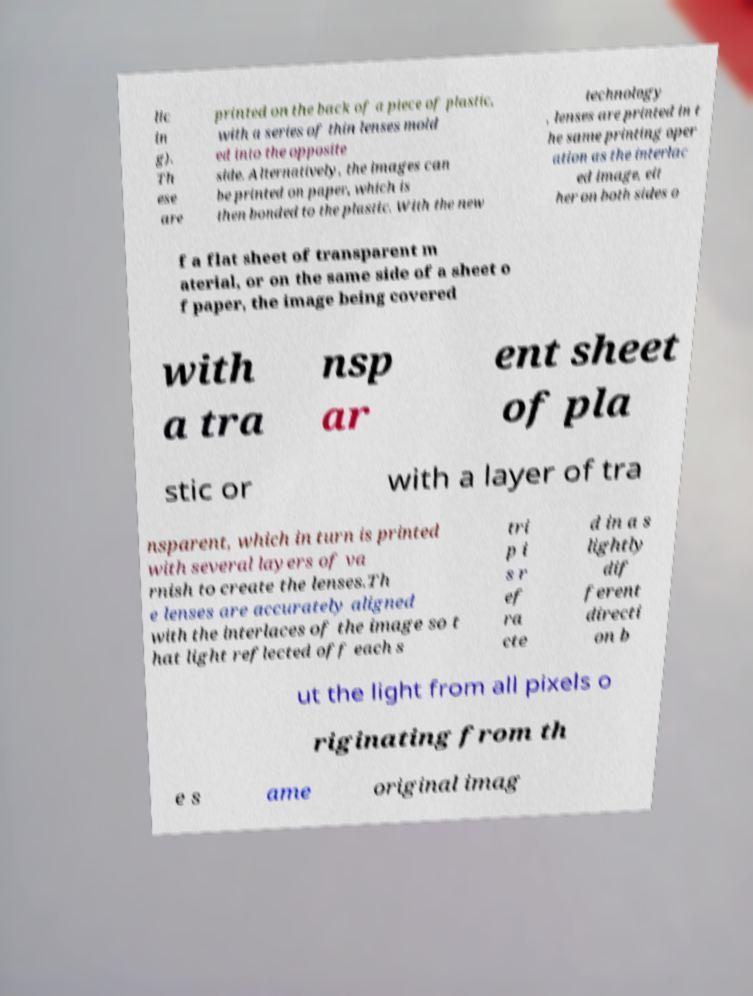Can you accurately transcribe the text from the provided image for me? lic in g). Th ese are printed on the back of a piece of plastic, with a series of thin lenses mold ed into the opposite side. Alternatively, the images can be printed on paper, which is then bonded to the plastic. With the new technology , lenses are printed in t he same printing oper ation as the interlac ed image, eit her on both sides o f a flat sheet of transparent m aterial, or on the same side of a sheet o f paper, the image being covered with a tra nsp ar ent sheet of pla stic or with a layer of tra nsparent, which in turn is printed with several layers of va rnish to create the lenses.Th e lenses are accurately aligned with the interlaces of the image so t hat light reflected off each s tri p i s r ef ra cte d in a s lightly dif ferent directi on b ut the light from all pixels o riginating from th e s ame original imag 